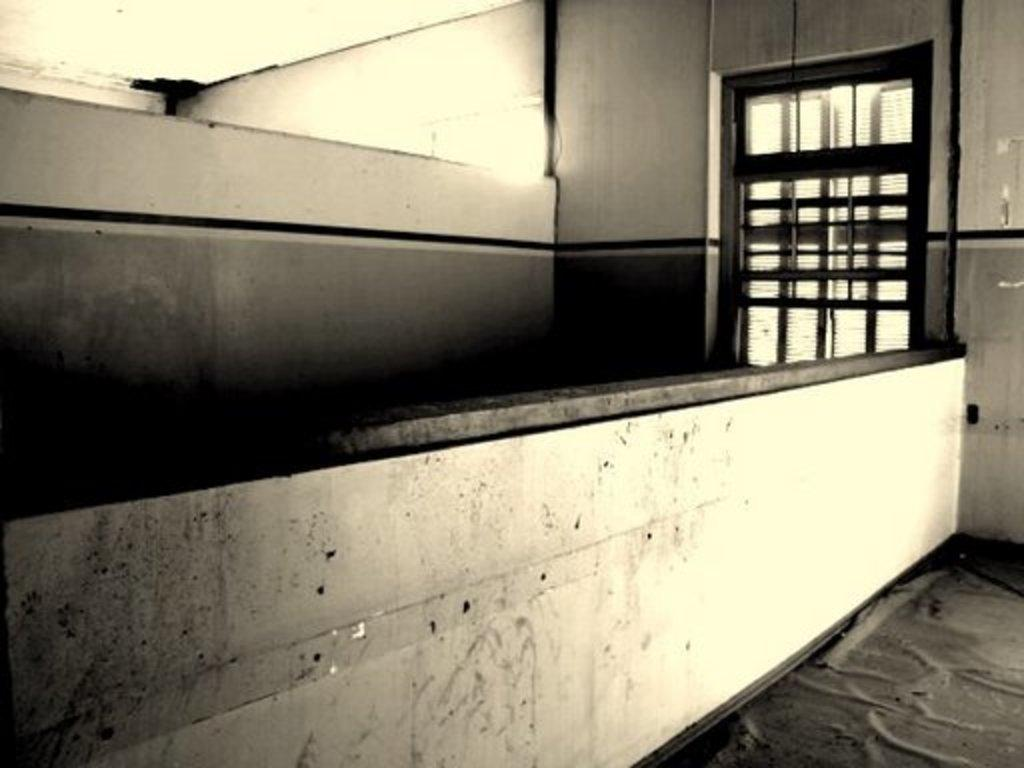What is the main structure visible in the image? There is a wall in the image. Can you describe any openings or features in the wall? Yes, there is a window on the right side of the image. What song is being sung by the letters in the image? There are no letters or singing in the image; it only features a wall with a window. 